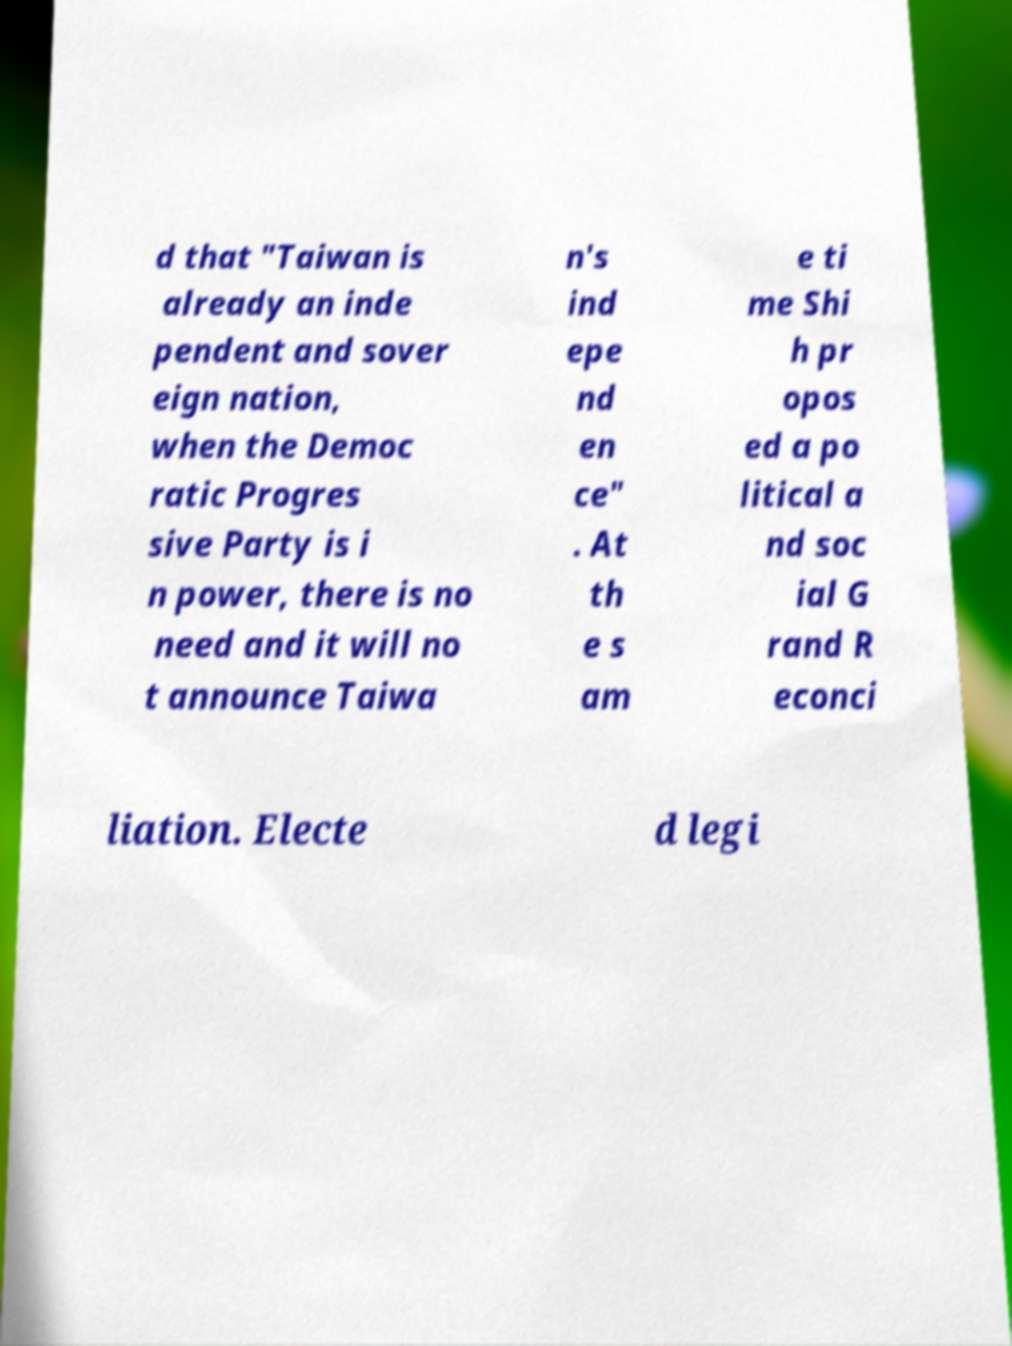What messages or text are displayed in this image? I need them in a readable, typed format. d that "Taiwan is already an inde pendent and sover eign nation, when the Democ ratic Progres sive Party is i n power, there is no need and it will no t announce Taiwa n's ind epe nd en ce" . At th e s am e ti me Shi h pr opos ed a po litical a nd soc ial G rand R econci liation. Electe d legi 